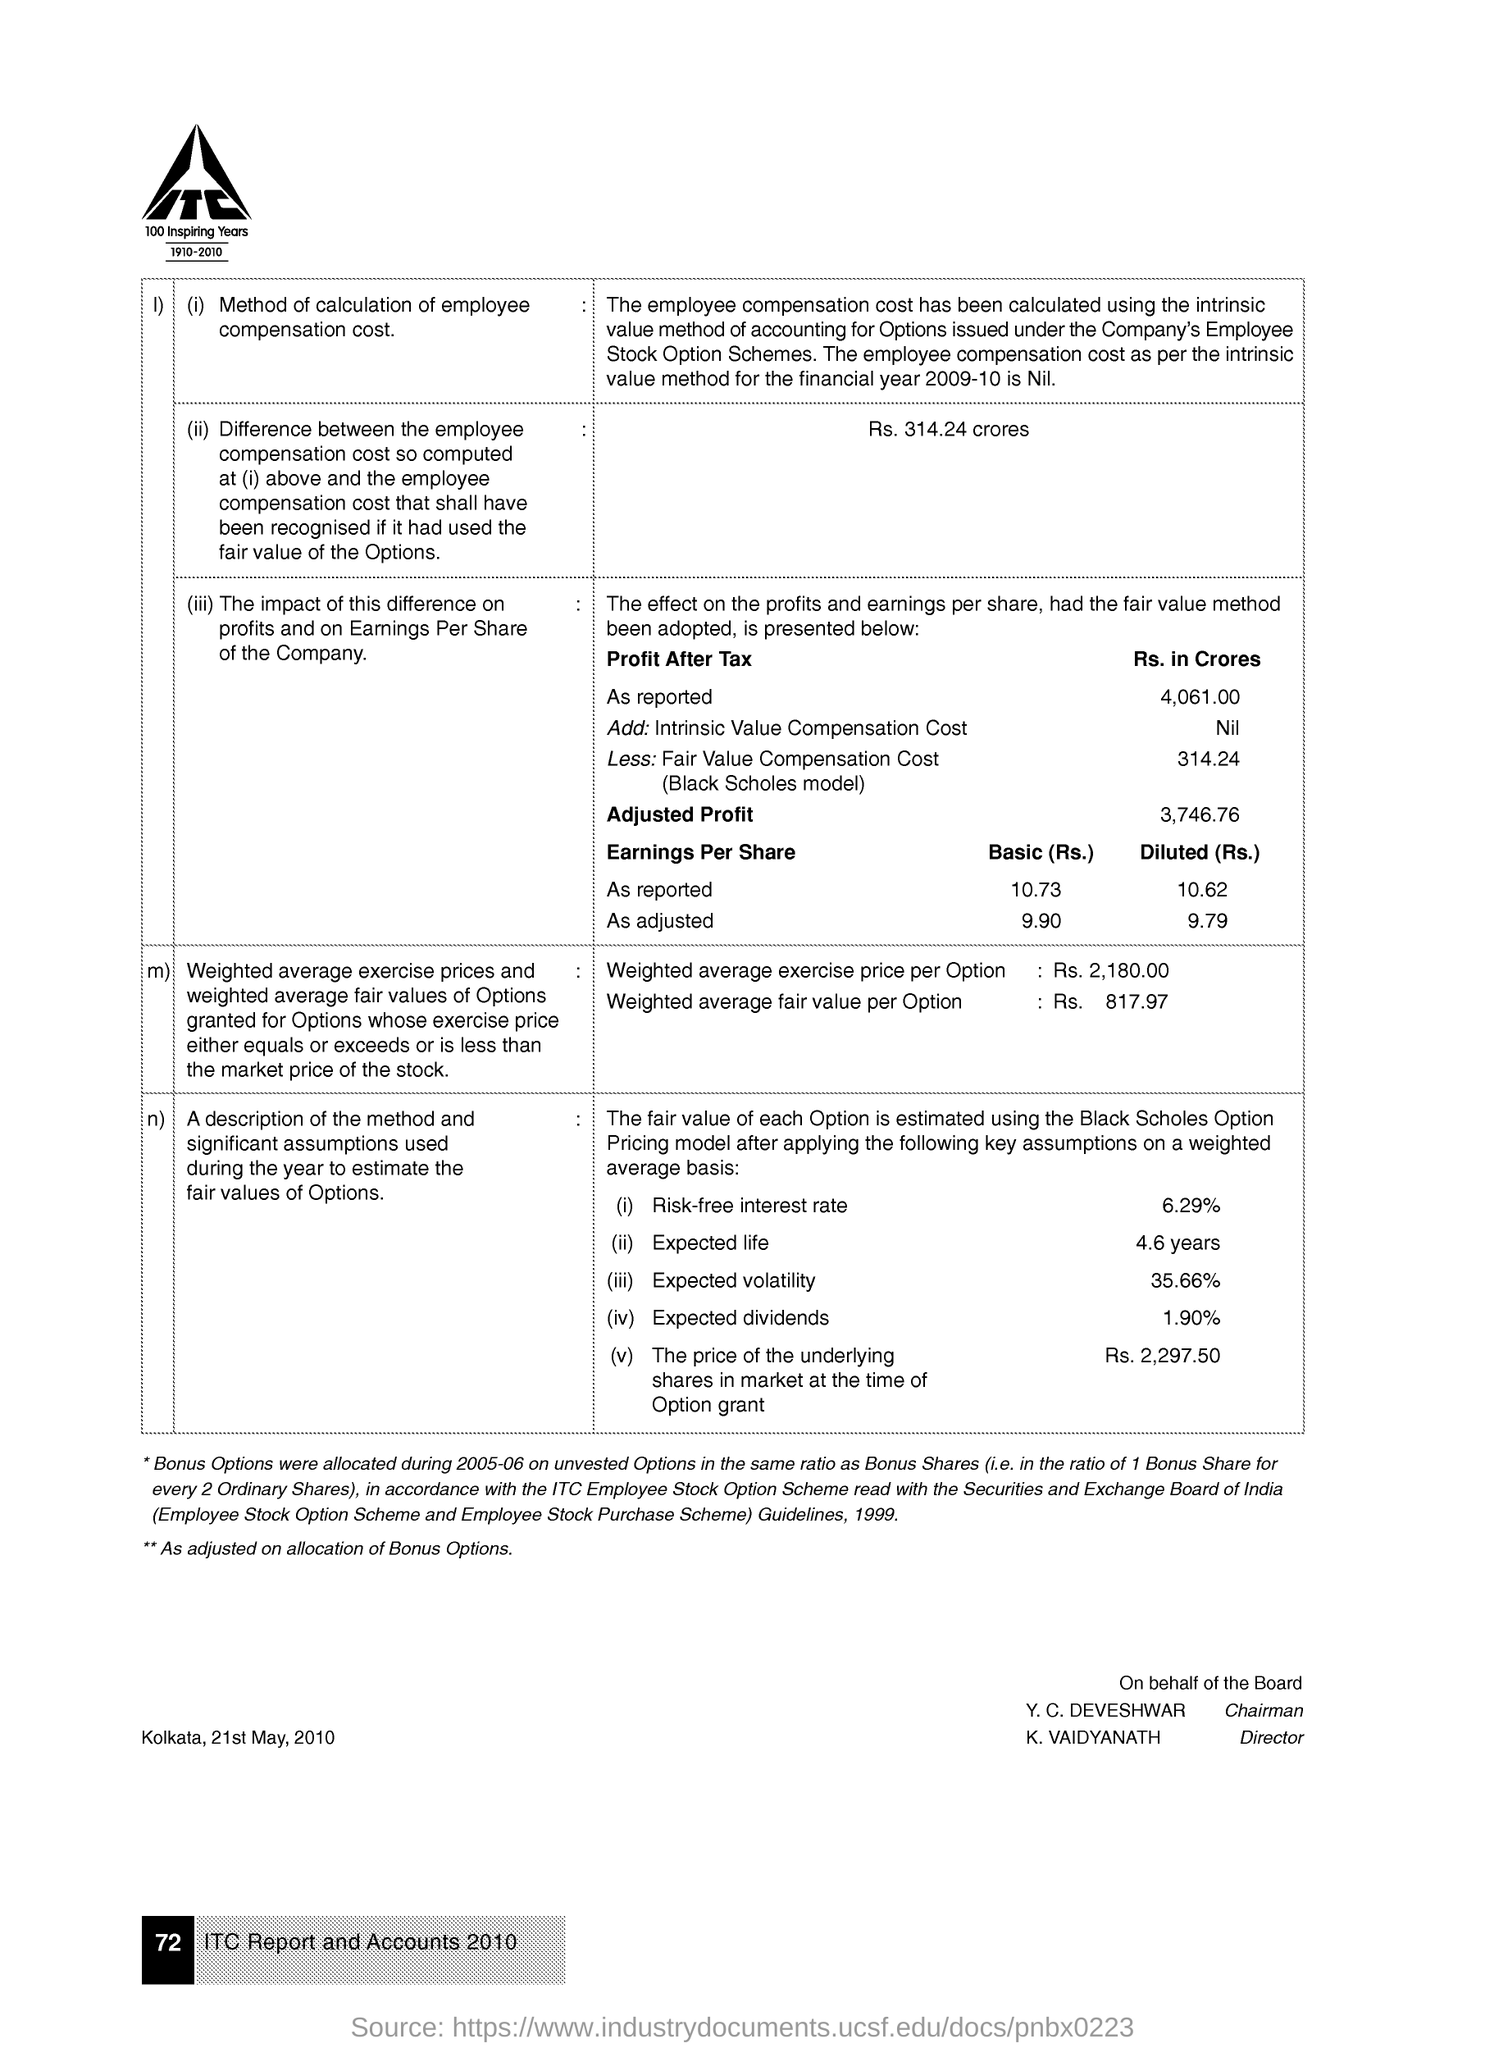Outline some significant characteristics in this image. The expected volatility is 35.66%. The weighted average exercise price per option is Rs. 2,180.00. The weighted average fair value per option was Rs. 817.97. It is known that K. Vaidyanath serves as the Director. The risk-free interest rate is 6.29%. 